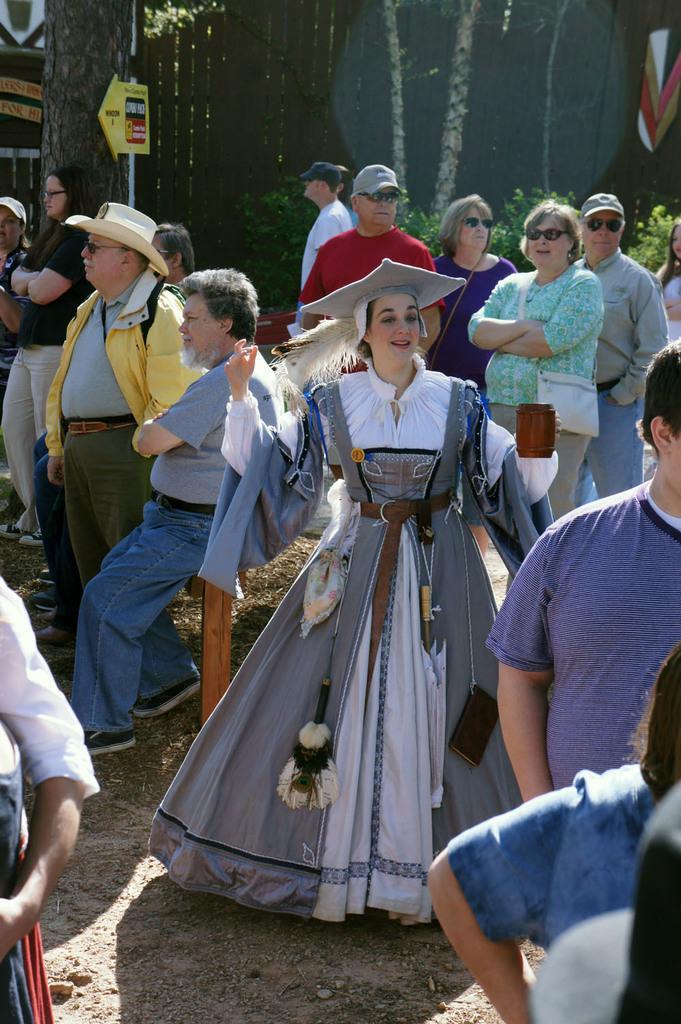How would you summarize this image in a sentence or two? In the center of the image we can see a few people are sitting and a few people are standing and they are in different costumes. Among them, we can see a few people are wearing hats, few people are wearing glasses and one person is smiling. On the left side of the image, we can see one human hand and clothes. On the right side of the image, we can see a few people. In the background there is a fence, plants, one sign board and a few other objects. 